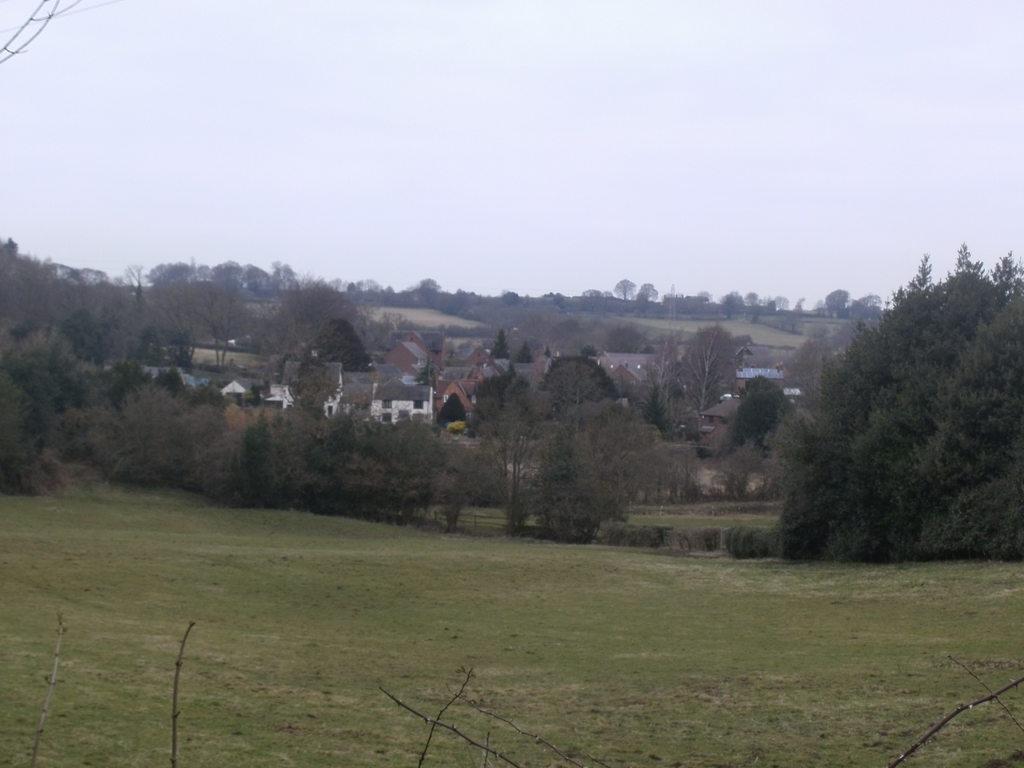How would you summarize this image in a sentence or two? In this picture there are buildings and trees. At the top there is sky. At the bottom there is grass. In the foreground there are tree branches. 